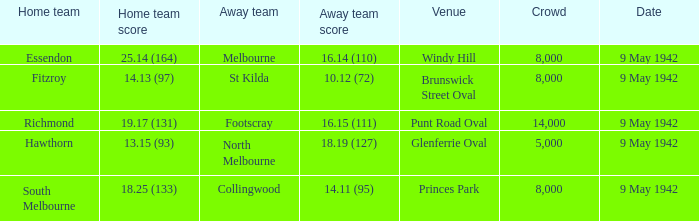How large was the crowd with a home team score of 18.25 (133)? 8000.0. 